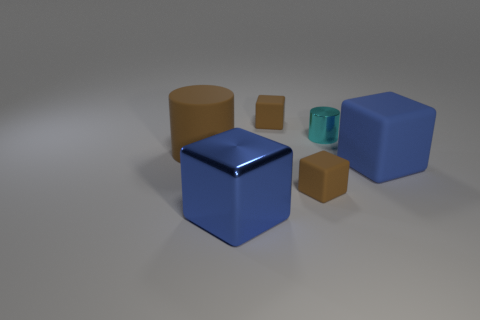Is the large shiny cube the same color as the big rubber block?
Provide a succinct answer. Yes. There is a tiny cyan object; is its shape the same as the big matte thing that is behind the big blue rubber cube?
Offer a very short reply. Yes. What number of cylinders are either brown matte objects or blue things?
Ensure brevity in your answer.  1. What is the color of the metallic block?
Give a very brief answer. Blue. Is the number of large blue matte things greater than the number of rubber cubes?
Keep it short and to the point. No. What number of objects are either rubber objects to the right of the small cyan object or big cyan spheres?
Ensure brevity in your answer.  1. Is the material of the cyan cylinder the same as the large brown cylinder?
Your answer should be very brief. No. The blue metal object that is the same shape as the big blue matte object is what size?
Your answer should be compact. Large. Does the big thing right of the cyan shiny object have the same shape as the brown object left of the large blue metal thing?
Provide a succinct answer. No. Does the cyan object have the same size as the blue cube that is on the right side of the blue metallic cube?
Keep it short and to the point. No. 